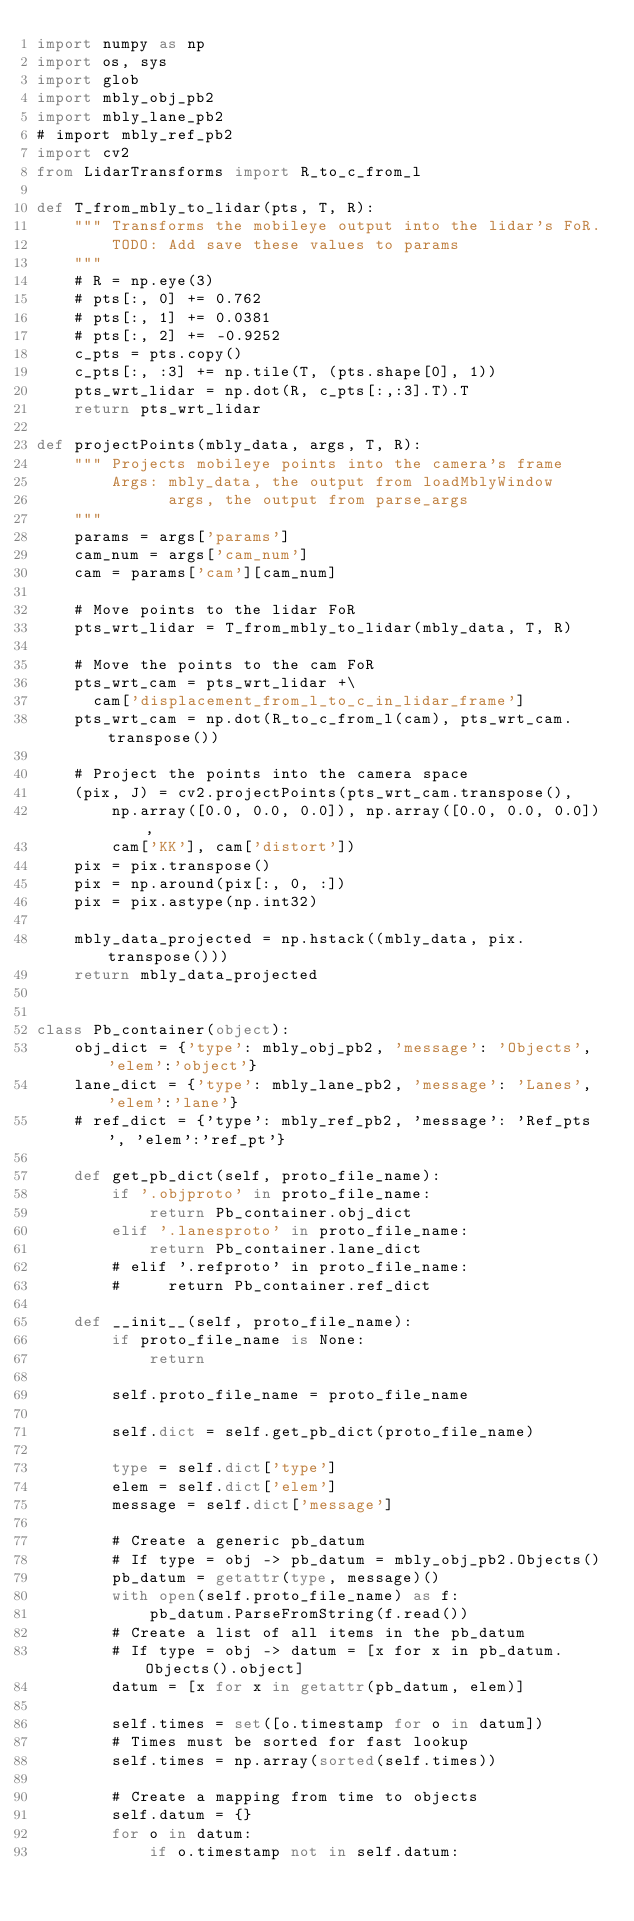Convert code to text. <code><loc_0><loc_0><loc_500><loc_500><_Python_>import numpy as np
import os, sys
import glob
import mbly_obj_pb2
import mbly_lane_pb2
# import mbly_ref_pb2
import cv2
from LidarTransforms import R_to_c_from_l

def T_from_mbly_to_lidar(pts, T, R):
    """ Transforms the mobileye output into the lidar's FoR.
        TODO: Add save these values to params
    """
    # R = np.eye(3)
    # pts[:, 0] += 0.762
    # pts[:, 1] += 0.0381
    # pts[:, 2] += -0.9252
    c_pts = pts.copy()
    c_pts[:, :3] += np.tile(T, (pts.shape[0], 1))
    pts_wrt_lidar = np.dot(R, c_pts[:,:3].T).T
    return pts_wrt_lidar

def projectPoints(mbly_data, args, T, R):
    """ Projects mobileye points into the camera's frame
        Args: mbly_data, the output from loadMblyWindow
              args, the output from parse_args
    """
    params = args['params']
    cam_num = args['cam_num']
    cam = params['cam'][cam_num]

    # Move points to the lidar FoR
    pts_wrt_lidar = T_from_mbly_to_lidar(mbly_data, T, R)

    # Move the points to the cam FoR
    pts_wrt_cam = pts_wrt_lidar +\
      cam['displacement_from_l_to_c_in_lidar_frame']
    pts_wrt_cam = np.dot(R_to_c_from_l(cam), pts_wrt_cam.transpose())

    # Project the points into the camera space
    (pix, J) = cv2.projectPoints(pts_wrt_cam.transpose(),
        np.array([0.0, 0.0, 0.0]), np.array([0.0, 0.0, 0.0]),
        cam['KK'], cam['distort'])
    pix = pix.transpose()
    pix = np.around(pix[:, 0, :])
    pix = pix.astype(np.int32)

    mbly_data_projected = np.hstack((mbly_data, pix.transpose()))
    return mbly_data_projected


class Pb_container(object):
    obj_dict = {'type': mbly_obj_pb2, 'message': 'Objects', 'elem':'object'}
    lane_dict = {'type': mbly_lane_pb2, 'message': 'Lanes', 'elem':'lane'}
    # ref_dict = {'type': mbly_ref_pb2, 'message': 'Ref_pts', 'elem':'ref_pt'}

    def get_pb_dict(self, proto_file_name):
        if '.objproto' in proto_file_name:
            return Pb_container.obj_dict
        elif '.lanesproto' in proto_file_name:
            return Pb_container.lane_dict
        # elif '.refproto' in proto_file_name:
        #     return Pb_container.ref_dict

    def __init__(self, proto_file_name):
        if proto_file_name is None:
            return

        self.proto_file_name = proto_file_name

        self.dict = self.get_pb_dict(proto_file_name)

        type = self.dict['type']
        elem = self.dict['elem']
        message = self.dict['message']

        # Create a generic pb_datum
        # If type = obj -> pb_datum = mbly_obj_pb2.Objects()
        pb_datum = getattr(type, message)()
        with open(self.proto_file_name) as f:
            pb_datum.ParseFromString(f.read())
        # Create a list of all items in the pb_datum
        # If type = obj -> datum = [x for x in pb_datum.Objects().object]
        datum = [x for x in getattr(pb_datum, elem)]

        self.times = set([o.timestamp for o in datum])
        # Times must be sorted for fast lookup
        self.times = np.array(sorted(self.times))

        # Create a mapping from time to objects
        self.datum = {}
        for o in datum:
            if o.timestamp not in self.datum:</code> 